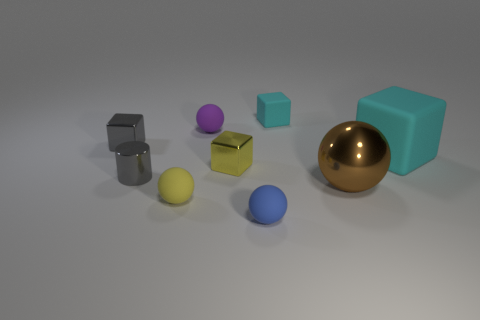Are there more small gray shiny objects behind the yellow block than tiny yellow blocks to the right of the gray block?
Your answer should be compact. No. There is a cyan thing that is the same size as the yellow cube; what is it made of?
Offer a very short reply. Rubber. The tiny cyan matte thing has what shape?
Your answer should be compact. Cube. How many yellow objects are either big metal objects or tiny cylinders?
Your answer should be compact. 0. There is a yellow sphere that is made of the same material as the tiny purple object; what size is it?
Make the answer very short. Small. Do the yellow thing behind the large shiny sphere and the small ball that is behind the yellow ball have the same material?
Your response must be concise. No. How many balls are large brown objects or purple things?
Your response must be concise. 2. How many purple rubber spheres are in front of the cyan rubber thing that is on the right side of the small block that is to the right of the blue ball?
Offer a terse response. 0. There is a tiny yellow object that is the same shape as the large shiny object; what material is it?
Provide a short and direct response. Rubber. Are there any other things that have the same material as the small gray cylinder?
Offer a terse response. Yes. 